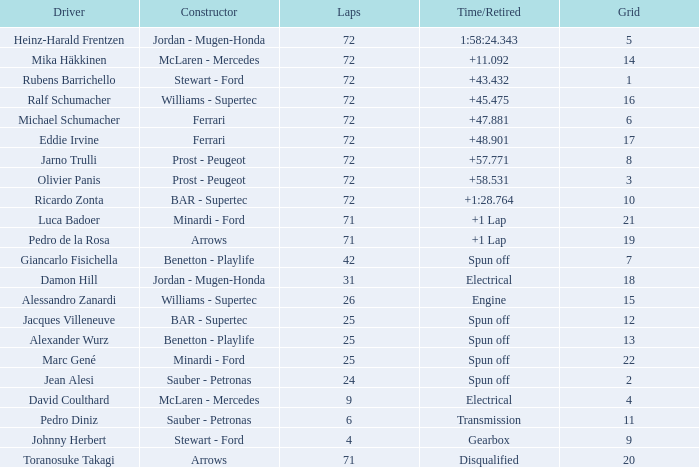When Jean Alesi had laps less than 24, what was his highest grid? None. 